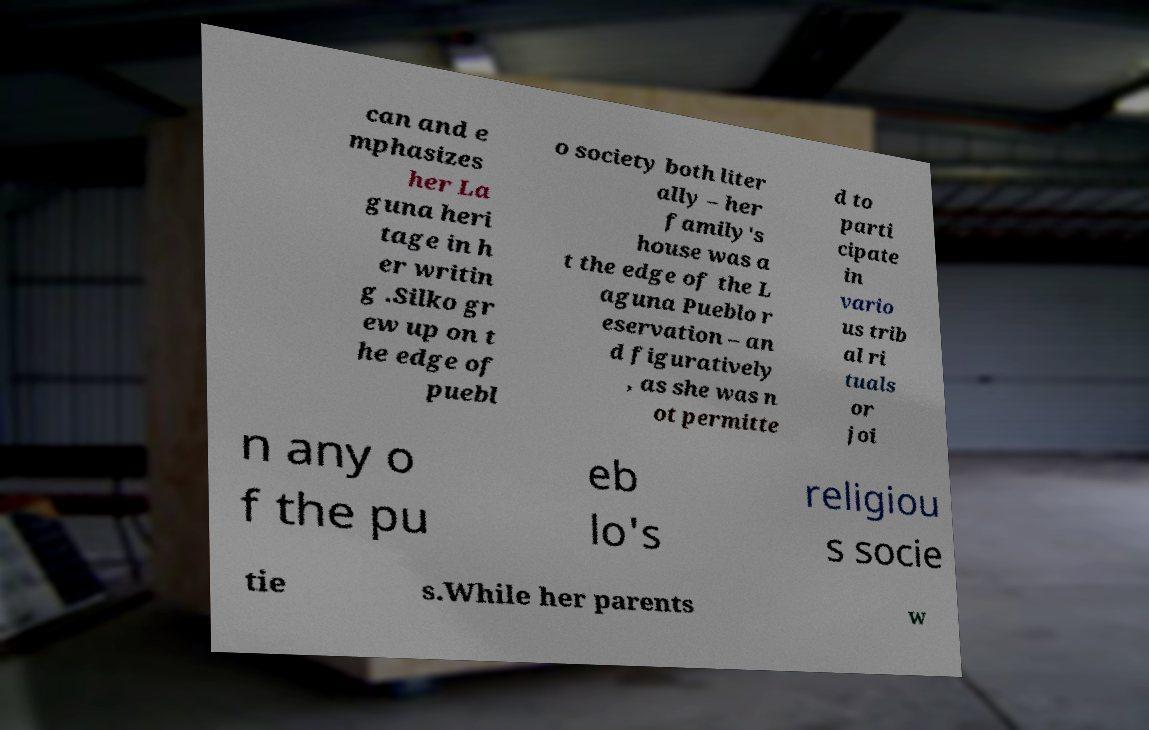Can you read and provide the text displayed in the image?This photo seems to have some interesting text. Can you extract and type it out for me? can and e mphasizes her La guna heri tage in h er writin g .Silko gr ew up on t he edge of puebl o society both liter ally – her family's house was a t the edge of the L aguna Pueblo r eservation – an d figuratively , as she was n ot permitte d to parti cipate in vario us trib al ri tuals or joi n any o f the pu eb lo's religiou s socie tie s.While her parents w 